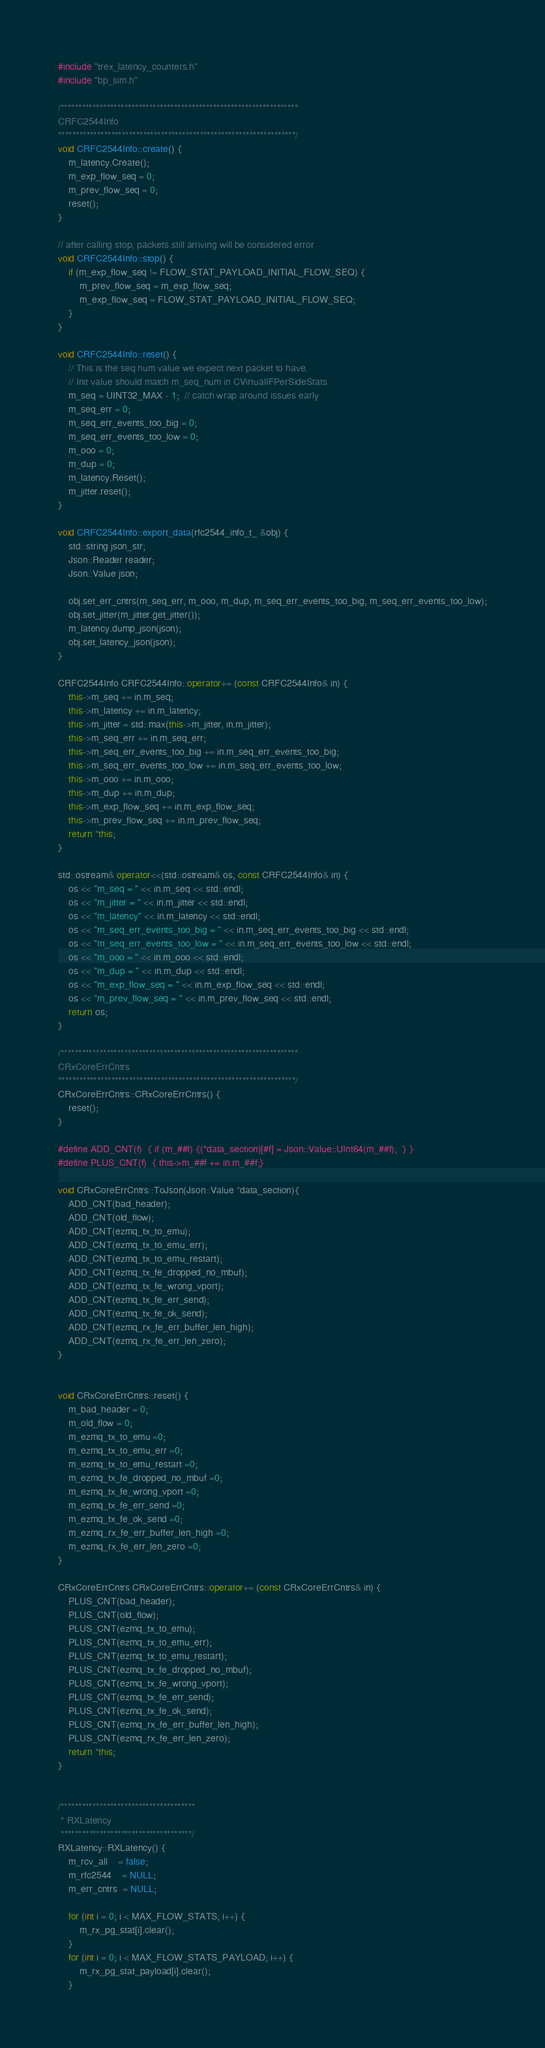<code> <loc_0><loc_0><loc_500><loc_500><_C++_>#include "trex_latency_counters.h"
#include "bp_sim.h"

/*******************************************************************
CRFC2544Info
*******************************************************************/
void CRFC2544Info::create() {
    m_latency.Create();
    m_exp_flow_seq = 0;
    m_prev_flow_seq = 0;
    reset();
}

// after calling stop, packets still arriving will be considered error
void CRFC2544Info::stop() {
    if (m_exp_flow_seq != FLOW_STAT_PAYLOAD_INITIAL_FLOW_SEQ) {
        m_prev_flow_seq = m_exp_flow_seq;
        m_exp_flow_seq = FLOW_STAT_PAYLOAD_INITIAL_FLOW_SEQ;
    }
}

void CRFC2544Info::reset() {
    // This is the seq num value we expect next packet to have.
    // Init value should match m_seq_num in CVirtualIFPerSideStats
    m_seq = UINT32_MAX - 1;  // catch wrap around issues early
    m_seq_err = 0;
    m_seq_err_events_too_big = 0;
    m_seq_err_events_too_low = 0;
    m_ooo = 0;
    m_dup = 0;
    m_latency.Reset();
    m_jitter.reset();
}

void CRFC2544Info::export_data(rfc2544_info_t_ &obj) {
    std::string json_str;
    Json::Reader reader;
    Json::Value json;

    obj.set_err_cntrs(m_seq_err, m_ooo, m_dup, m_seq_err_events_too_big, m_seq_err_events_too_low);
    obj.set_jitter(m_jitter.get_jitter());
    m_latency.dump_json(json);
    obj.set_latency_json(json);
}

CRFC2544Info CRFC2544Info::operator+= (const CRFC2544Info& in) {
    this->m_seq += in.m_seq;
    this->m_latency += in.m_latency;
    this->m_jitter = std::max(this->m_jitter, in.m_jitter);
    this->m_seq_err += in.m_seq_err;
    this->m_seq_err_events_too_big += in.m_seq_err_events_too_big;
    this->m_seq_err_events_too_low += in.m_seq_err_events_too_low;
    this->m_ooo += in.m_ooo;
    this->m_dup += in.m_dup;
    this->m_exp_flow_seq += in.m_exp_flow_seq;
    this->m_prev_flow_seq += in.m_prev_flow_seq;
    return *this;
}

std::ostream& operator<<(std::ostream& os, const CRFC2544Info& in) {
    os << "m_seq = " << in.m_seq << std::endl;
    os << "m_jitter = " << in.m_jitter << std::endl;
    os << "m_latency" << in.m_latency << std::endl;
    os << "m_seq_err_events_too_big = " << in.m_seq_err_events_too_big << std::endl;
    os << "m_seq_err_events_too_low = " << in.m_seq_err_events_too_low << std::endl;
    os << "m_ooo = " << in.m_ooo << std::endl;
    os << "m_dup = " << in.m_dup << std::endl;
    os << "m_exp_flow_seq = " << in.m_exp_flow_seq << std::endl;
    os << "m_prev_flow_seq = " << in.m_prev_flow_seq << std::endl;
    return os;
}

/*******************************************************************
CRxCoreErrCntrs
*******************************************************************/
CRxCoreErrCntrs::CRxCoreErrCntrs() {
    reset();
}

#define ADD_CNT(f)  { if (m_##f) {(*data_section)[#f] = Json::Value::UInt64(m_##f);  } } 
#define PLUS_CNT(f)  { this->m_##f += in.m_##f;}

void CRxCoreErrCntrs::ToJson(Json::Value *data_section){
    ADD_CNT(bad_header);
    ADD_CNT(old_flow);
    ADD_CNT(ezmq_tx_to_emu);
    ADD_CNT(ezmq_tx_to_emu_err);
    ADD_CNT(ezmq_tx_to_emu_restart);
    ADD_CNT(ezmq_tx_fe_dropped_no_mbuf);
    ADD_CNT(ezmq_tx_fe_wrong_vport);
    ADD_CNT(ezmq_tx_fe_err_send);
    ADD_CNT(ezmq_tx_fe_ok_send);
    ADD_CNT(ezmq_rx_fe_err_buffer_len_high);
    ADD_CNT(ezmq_rx_fe_err_len_zero);
}


void CRxCoreErrCntrs::reset() {
    m_bad_header = 0;
    m_old_flow = 0;
    m_ezmq_tx_to_emu =0;
    m_ezmq_tx_to_emu_err =0;
    m_ezmq_tx_to_emu_restart =0;
    m_ezmq_tx_fe_dropped_no_mbuf =0;
    m_ezmq_tx_fe_wrong_vport =0;
    m_ezmq_tx_fe_err_send =0;
    m_ezmq_tx_fe_ok_send =0;
    m_ezmq_rx_fe_err_buffer_len_high =0;
    m_ezmq_rx_fe_err_len_zero =0;
}

CRxCoreErrCntrs CRxCoreErrCntrs::operator+= (const CRxCoreErrCntrs& in) {
    PLUS_CNT(bad_header);
    PLUS_CNT(old_flow);
    PLUS_CNT(ezmq_tx_to_emu);
    PLUS_CNT(ezmq_tx_to_emu_err);
    PLUS_CNT(ezmq_tx_to_emu_restart);
    PLUS_CNT(ezmq_tx_fe_dropped_no_mbuf);
    PLUS_CNT(ezmq_tx_fe_wrong_vport);
    PLUS_CNT(ezmq_tx_fe_err_send);
    PLUS_CNT(ezmq_tx_fe_ok_send);
    PLUS_CNT(ezmq_rx_fe_err_buffer_len_high);
    PLUS_CNT(ezmq_rx_fe_err_len_zero);
    return *this;
}


/**************************************
 * RXLatency
 *************************************/
RXLatency::RXLatency() {
    m_rcv_all    = false;
    m_rfc2544    = NULL;
    m_err_cntrs  = NULL;

    for (int i = 0; i < MAX_FLOW_STATS; i++) {
        m_rx_pg_stat[i].clear();
    }
    for (int i = 0; i < MAX_FLOW_STATS_PAYLOAD; i++) {
        m_rx_pg_stat_payload[i].clear();
    }
</code> 